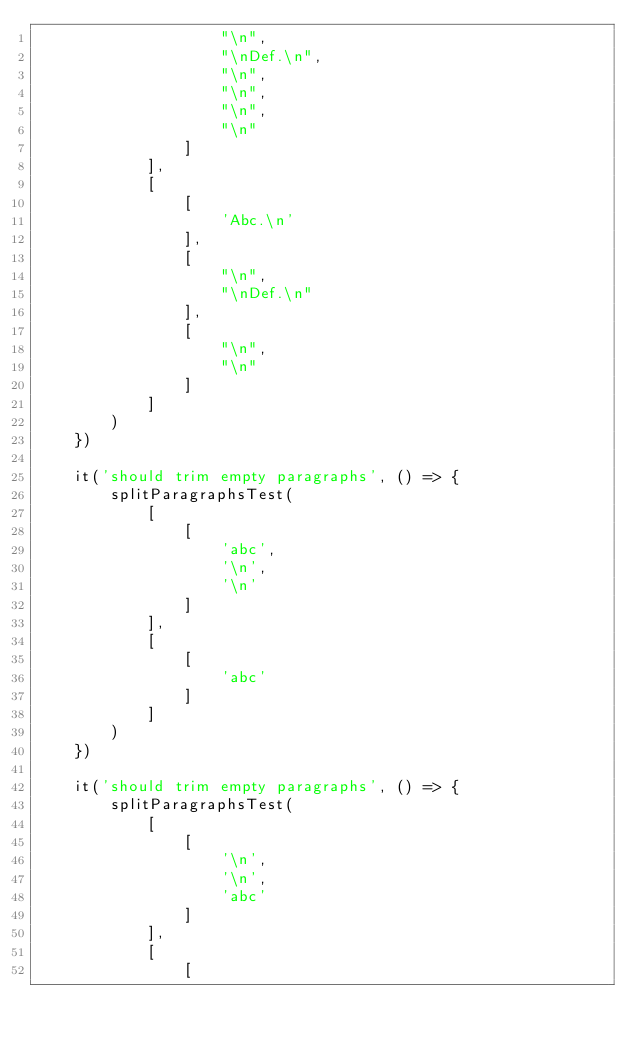<code> <loc_0><loc_0><loc_500><loc_500><_JavaScript_>					"\n",
					"\nDef.\n",
					"\n",
					"\n",
					"\n",
					"\n"
				]
			],
			[
				[
					'Abc.\n'
				],
				[
					"\n",
					"\nDef.\n"
				],
				[
					"\n",
					"\n"
				]
			]
		)
	})

	it('should trim empty paragraphs', () => {
		splitParagraphsTest(
			[
				[
					'abc',
					'\n',
					'\n'
				]
			],
			[
				[
					'abc'
				]
			]
		)
	})

	it('should trim empty paragraphs', () => {
		splitParagraphsTest(
			[
				[
					'\n',
					'\n',
					'abc'
				]
			],
			[
				[</code> 